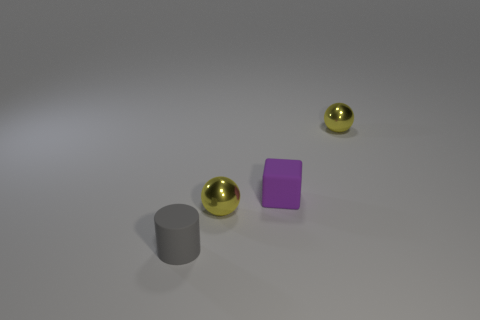Add 1 small brown objects. How many objects exist? 5 Subtract all cylinders. How many objects are left? 3 Add 1 cubes. How many cubes exist? 2 Subtract 0 purple balls. How many objects are left? 4 Subtract all cylinders. Subtract all tiny gray objects. How many objects are left? 2 Add 3 tiny gray rubber objects. How many tiny gray rubber objects are left? 4 